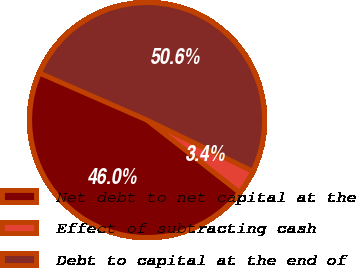Convert chart. <chart><loc_0><loc_0><loc_500><loc_500><pie_chart><fcel>Net debt to net capital at the<fcel>Effect of subtracting cash<fcel>Debt to capital at the end of<nl><fcel>46.0%<fcel>3.39%<fcel>50.6%<nl></chart> 